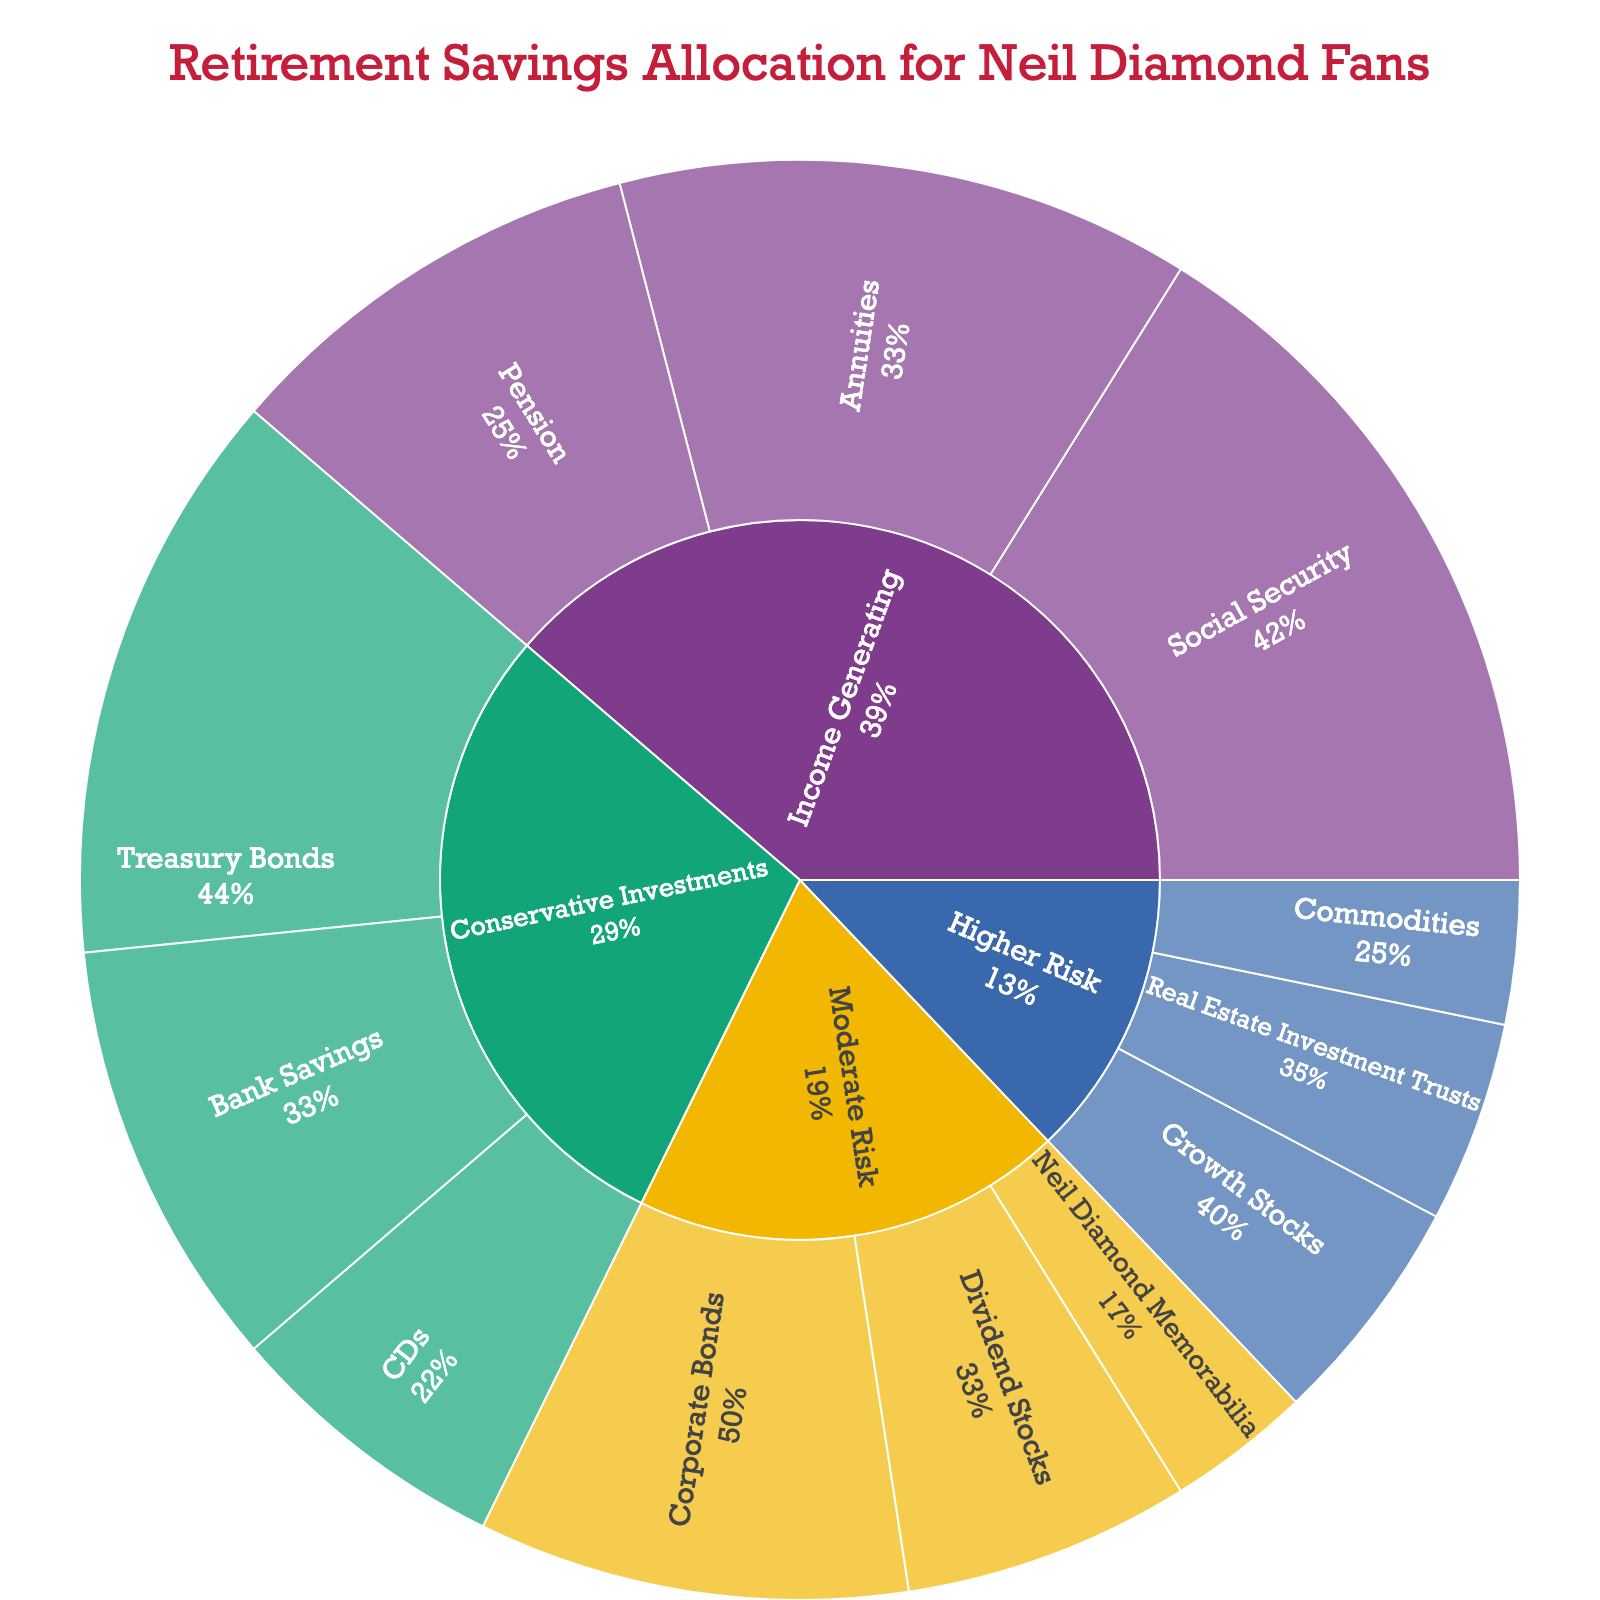What are the main categories represented in the plot? The main categories are the largest segments in the sunburst plot, which correspond to the outermost rings around the center. They represent the major types of investments.
Answer: Conservative Investments, Moderate Risk, Higher Risk, Income Generating How much of the total retirement savings is allocated to "Neil Diamond Memorabilia"? Locate "Neil Diamond Memorabilia" under the "Moderate Risk" category. The value next to it indicates its percentage of the total.
Answer: 5% Which category holds the highest percentage in retirement savings? Examine the relative sizes of the segments at the highest level of the sunburst to determine which one is the largest.
Answer: Income Generating What is the combined percentage allocated to "Annuities" and "Pension" within the "Income Generating" category? Locate "Income Generating" and identify the values for "Annuities" and "Pension". Sum these values to find the combined percentage.
Answer: 20% + 15% = 35% Is the allocation for "Commodities" higher or lower than that for "CDs"? Compare the values displayed next to "Commodities" under "Higher Risk" and "CDs" under "Conservative Investments".
Answer: Lower Within "Higher Risk" investments, what percentage is allocated to "Real Estate Investment Trusts" (REITs)? Find the segment labeled "Real Estate Investment Trusts" under the "Higher Risk" category and note its value.
Answer: 7% What is the total percentage of savings allocated to Conservative Investments? Sum the values for "Bank Savings", "CDs", and "Treasury Bonds" listed under the "Conservative Investments" category.
Answer: 15% + 10% + 20% = 45% Which subcategory under "Moderate Risk" has the smallest allocation, and what is its value? Compare the values under "Moderate Risk" for "Corporate Bonds", "Dividend Stocks", and "Neil Diamond Memorabilia". Identify the smallest value and its associated subcategory.
Answer: Neil Diamond Memorabilia, 5% How does the allocation to "Growth Stocks" compare to that of "Corporate Bonds"? Compare the values next to "Growth Stocks" under "Higher Risk" and "Corporate Bonds" under "Moderate Risk".
Answer: Lower Calculate the percentage difference between "Social Security" and "Treasury Bonds". Subtract the value of "Treasury Bonds" from "Social Security" and divide by "Treasury Bonds", then multiply by 100 to get the percentage difference.
Answer: ((25% - 20%) / 20%) * 100 = 25% 